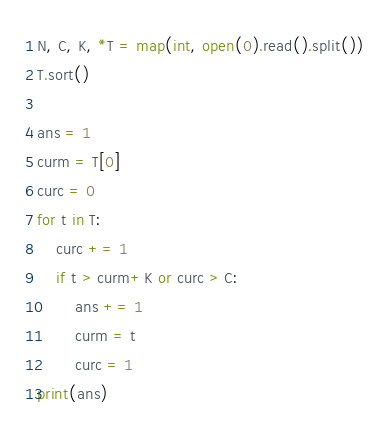Convert code to text. <code><loc_0><loc_0><loc_500><loc_500><_Python_>N, C, K, *T = map(int, open(0).read().split())
T.sort()

ans = 1
curm = T[0]
curc = 0
for t in T:
    curc += 1
    if t > curm+K or curc > C:
        ans += 1
        curm = t
        curc = 1
print(ans)
</code> 